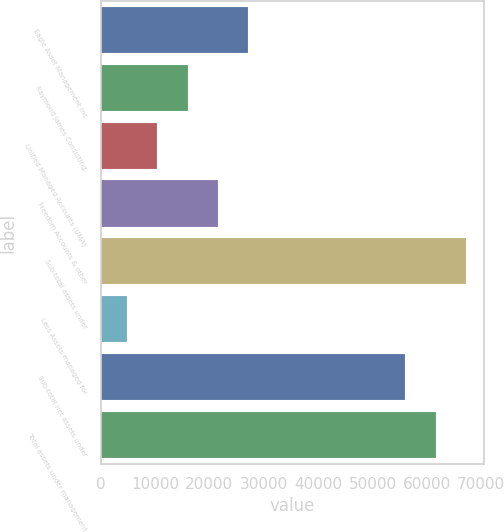Convert chart to OTSL. <chart><loc_0><loc_0><loc_500><loc_500><bar_chart><fcel>Eagle Asset Management Inc<fcel>Raymond James Consulting<fcel>Unified Managed Accounts (UMA)<fcel>Freedom Accounts & other<fcel>Sub-total assets under<fcel>Less Assets managed for<fcel>Sub-total net assets under<fcel>Total assets under management<nl><fcel>27194.6<fcel>15996.8<fcel>10397.9<fcel>21595.7<fcel>67186.8<fcel>4799<fcel>55989<fcel>61587.9<nl></chart> 